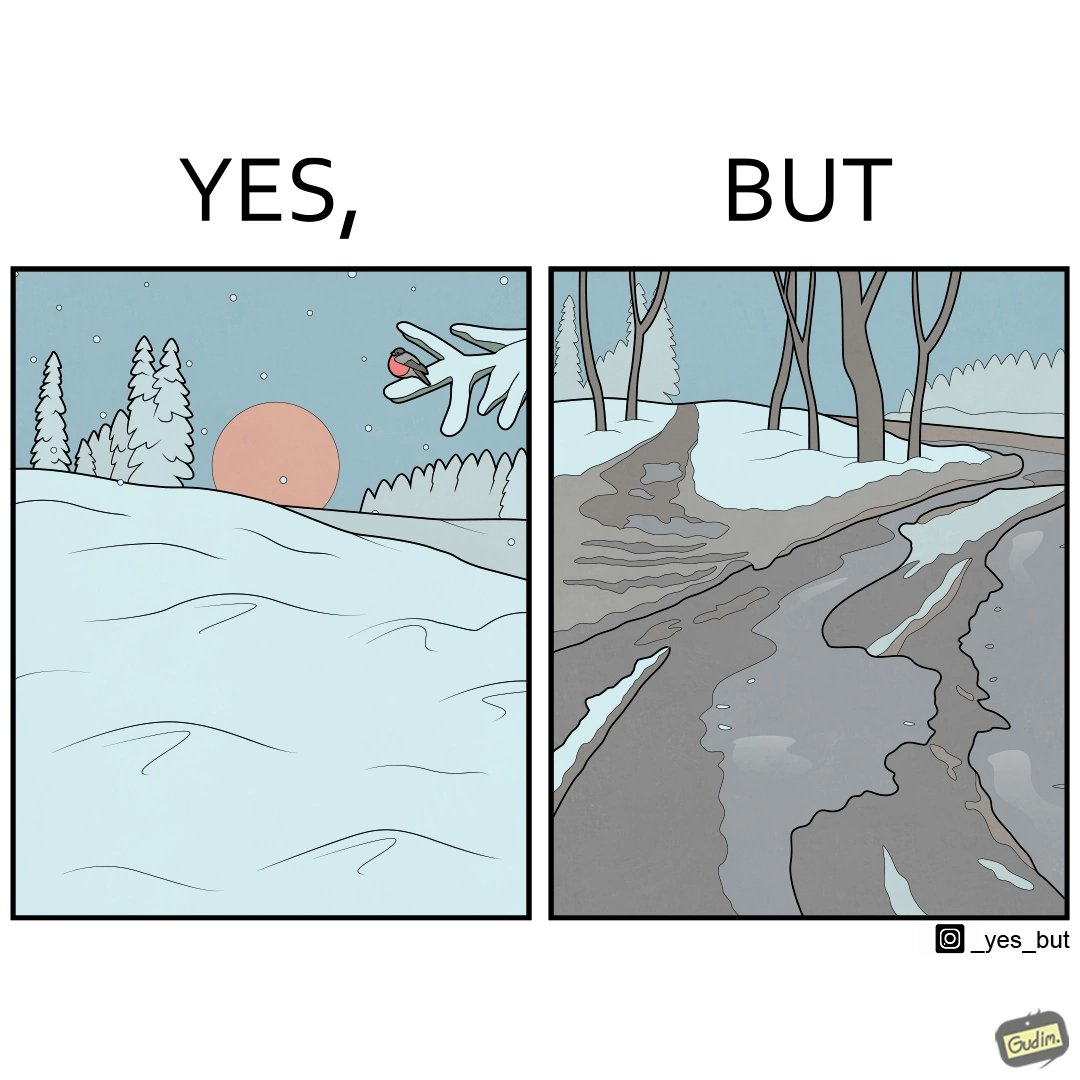What does this image depict? The image is funny, as from far, snow covered mountains look really scenic and completely white, but when zooming in near trees, the ground is partially covered in snow, and is not as scenic anymore. 